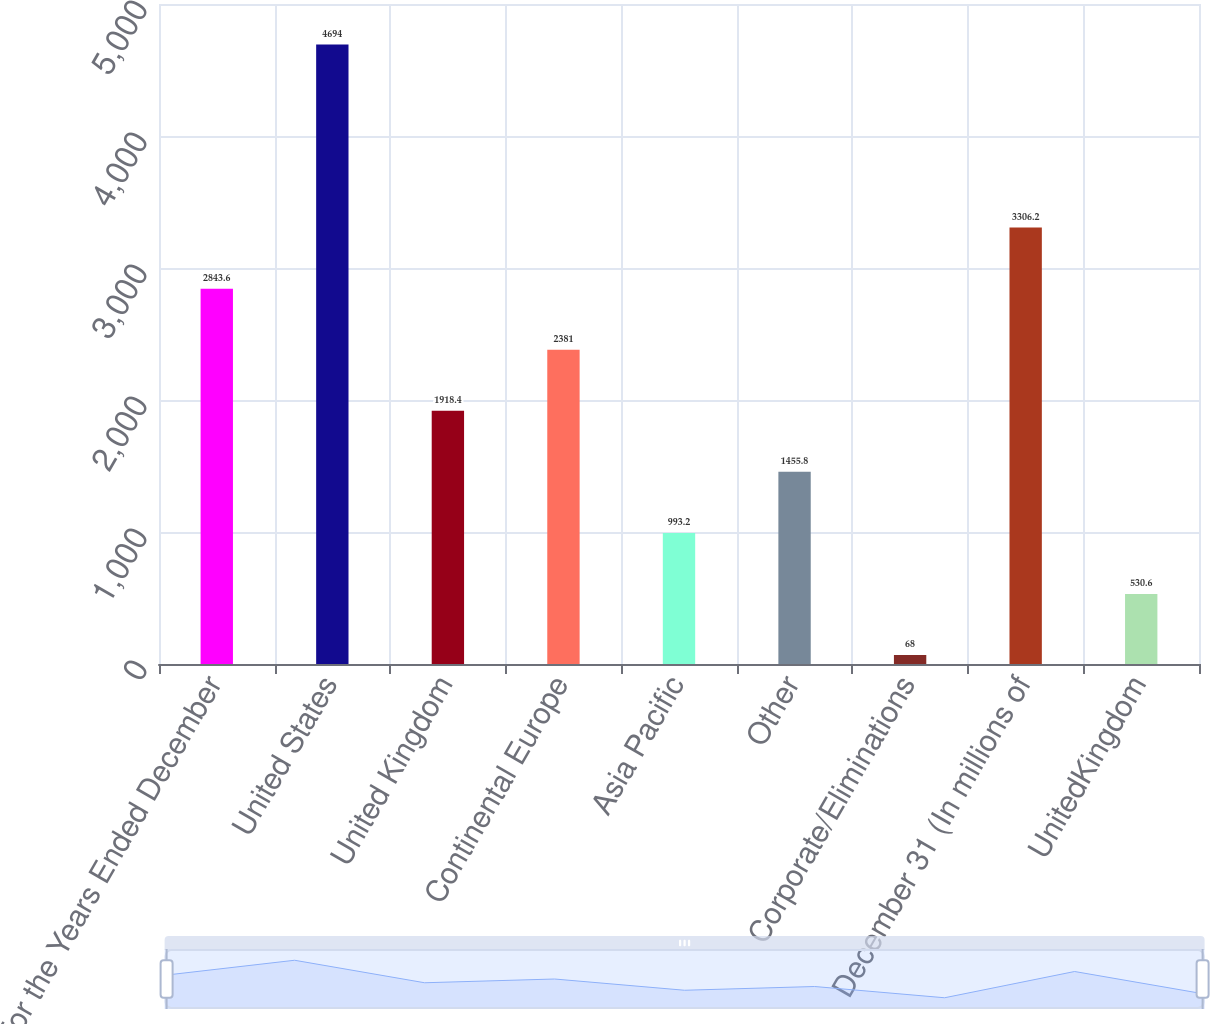Convert chart to OTSL. <chart><loc_0><loc_0><loc_500><loc_500><bar_chart><fcel>For the Years Ended December<fcel>United States<fcel>United Kingdom<fcel>Continental Europe<fcel>Asia Pacific<fcel>Other<fcel>Corporate/Eliminations<fcel>December 31 (In millions of<fcel>UnitedKingdom<nl><fcel>2843.6<fcel>4694<fcel>1918.4<fcel>2381<fcel>993.2<fcel>1455.8<fcel>68<fcel>3306.2<fcel>530.6<nl></chart> 